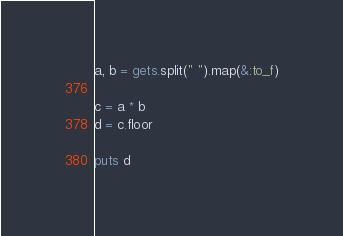Convert code to text. <code><loc_0><loc_0><loc_500><loc_500><_Ruby_>a, b = gets.split(" ").map(&:to_f)

c = a * b
d = c.floor

puts d</code> 